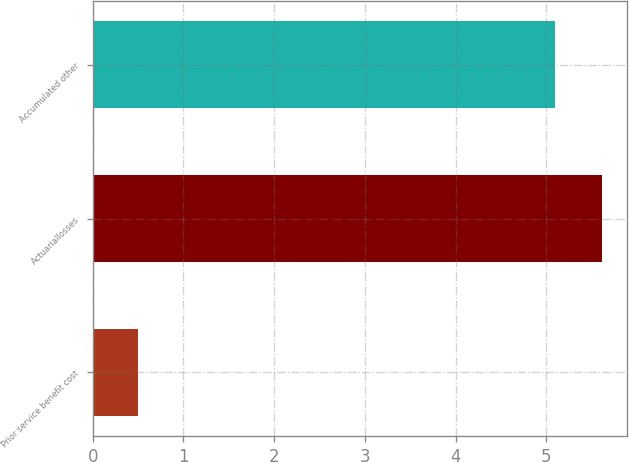<chart> <loc_0><loc_0><loc_500><loc_500><bar_chart><fcel>Prior service benefit cost<fcel>Actuariallosses<fcel>Accumulated other<nl><fcel>0.5<fcel>5.61<fcel>5.1<nl></chart> 